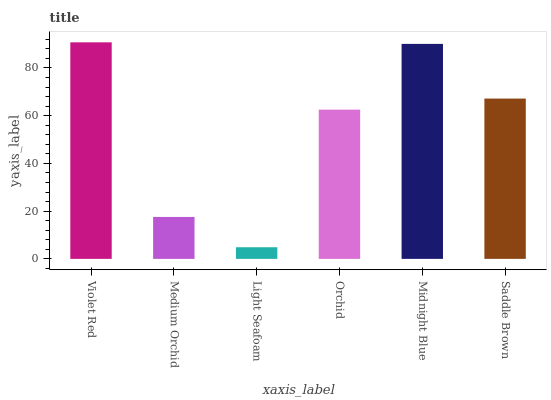Is Light Seafoam the minimum?
Answer yes or no. Yes. Is Violet Red the maximum?
Answer yes or no. Yes. Is Medium Orchid the minimum?
Answer yes or no. No. Is Medium Orchid the maximum?
Answer yes or no. No. Is Violet Red greater than Medium Orchid?
Answer yes or no. Yes. Is Medium Orchid less than Violet Red?
Answer yes or no. Yes. Is Medium Orchid greater than Violet Red?
Answer yes or no. No. Is Violet Red less than Medium Orchid?
Answer yes or no. No. Is Saddle Brown the high median?
Answer yes or no. Yes. Is Orchid the low median?
Answer yes or no. Yes. Is Violet Red the high median?
Answer yes or no. No. Is Light Seafoam the low median?
Answer yes or no. No. 